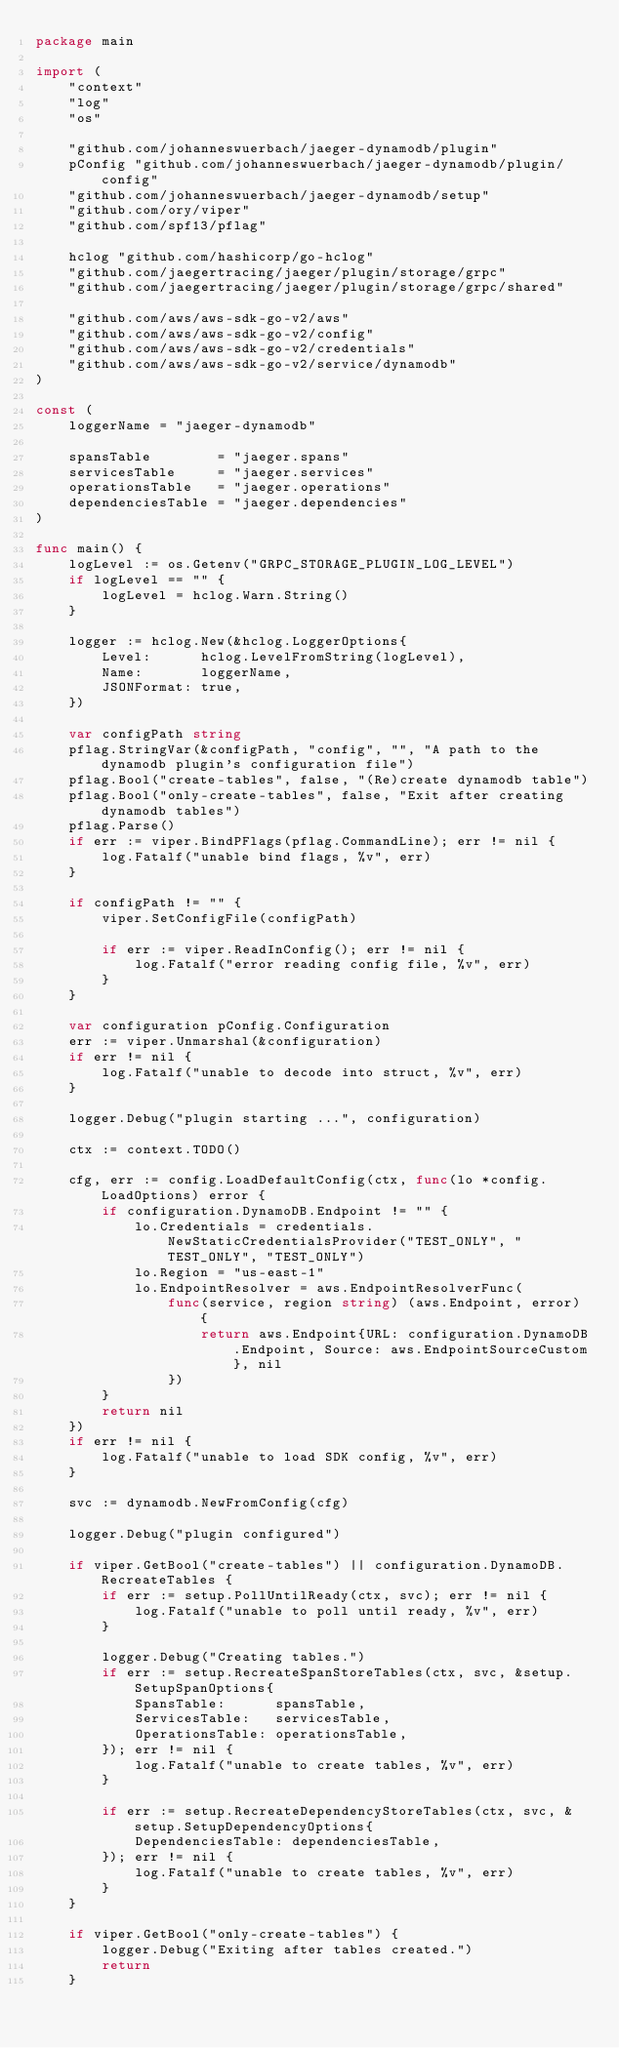Convert code to text. <code><loc_0><loc_0><loc_500><loc_500><_Go_>package main

import (
	"context"
	"log"
	"os"

	"github.com/johanneswuerbach/jaeger-dynamodb/plugin"
	pConfig "github.com/johanneswuerbach/jaeger-dynamodb/plugin/config"
	"github.com/johanneswuerbach/jaeger-dynamodb/setup"
	"github.com/ory/viper"
	"github.com/spf13/pflag"

	hclog "github.com/hashicorp/go-hclog"
	"github.com/jaegertracing/jaeger/plugin/storage/grpc"
	"github.com/jaegertracing/jaeger/plugin/storage/grpc/shared"

	"github.com/aws/aws-sdk-go-v2/aws"
	"github.com/aws/aws-sdk-go-v2/config"
	"github.com/aws/aws-sdk-go-v2/credentials"
	"github.com/aws/aws-sdk-go-v2/service/dynamodb"
)

const (
	loggerName = "jaeger-dynamodb"

	spansTable        = "jaeger.spans"
	servicesTable     = "jaeger.services"
	operationsTable   = "jaeger.operations"
	dependenciesTable = "jaeger.dependencies"
)

func main() {
	logLevel := os.Getenv("GRPC_STORAGE_PLUGIN_LOG_LEVEL")
	if logLevel == "" {
		logLevel = hclog.Warn.String()
	}

	logger := hclog.New(&hclog.LoggerOptions{
		Level:      hclog.LevelFromString(logLevel),
		Name:       loggerName,
		JSONFormat: true,
	})

	var configPath string
	pflag.StringVar(&configPath, "config", "", "A path to the dynamodb plugin's configuration file")
	pflag.Bool("create-tables", false, "(Re)create dynamodb table")
	pflag.Bool("only-create-tables", false, "Exit after creating dynamodb tables")
	pflag.Parse()
	if err := viper.BindPFlags(pflag.CommandLine); err != nil {
		log.Fatalf("unable bind flags, %v", err)
	}

	if configPath != "" {
		viper.SetConfigFile(configPath)

		if err := viper.ReadInConfig(); err != nil {
			log.Fatalf("error reading config file, %v", err)
		}
	}

	var configuration pConfig.Configuration
	err := viper.Unmarshal(&configuration)
	if err != nil {
		log.Fatalf("unable to decode into struct, %v", err)
	}

	logger.Debug("plugin starting ...", configuration)

	ctx := context.TODO()

	cfg, err := config.LoadDefaultConfig(ctx, func(lo *config.LoadOptions) error {
		if configuration.DynamoDB.Endpoint != "" {
			lo.Credentials = credentials.NewStaticCredentialsProvider("TEST_ONLY", "TEST_ONLY", "TEST_ONLY")
			lo.Region = "us-east-1"
			lo.EndpointResolver = aws.EndpointResolverFunc(
				func(service, region string) (aws.Endpoint, error) {
					return aws.Endpoint{URL: configuration.DynamoDB.Endpoint, Source: aws.EndpointSourceCustom}, nil
				})
		}
		return nil
	})
	if err != nil {
		log.Fatalf("unable to load SDK config, %v", err)
	}

	svc := dynamodb.NewFromConfig(cfg)

	logger.Debug("plugin configured")

	if viper.GetBool("create-tables") || configuration.DynamoDB.RecreateTables {
		if err := setup.PollUntilReady(ctx, svc); err != nil {
			log.Fatalf("unable to poll until ready, %v", err)
		}

		logger.Debug("Creating tables.")
		if err := setup.RecreateSpanStoreTables(ctx, svc, &setup.SetupSpanOptions{
			SpansTable:      spansTable,
			ServicesTable:   servicesTable,
			OperationsTable: operationsTable,
		}); err != nil {
			log.Fatalf("unable to create tables, %v", err)
		}

		if err := setup.RecreateDependencyStoreTables(ctx, svc, &setup.SetupDependencyOptions{
			DependenciesTable: dependenciesTable,
		}); err != nil {
			log.Fatalf("unable to create tables, %v", err)
		}
	}

	if viper.GetBool("only-create-tables") {
		logger.Debug("Exiting after tables created.")
		return
	}
</code> 